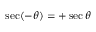<formula> <loc_0><loc_0><loc_500><loc_500>\sec ( - \theta ) = + \sec \theta</formula> 